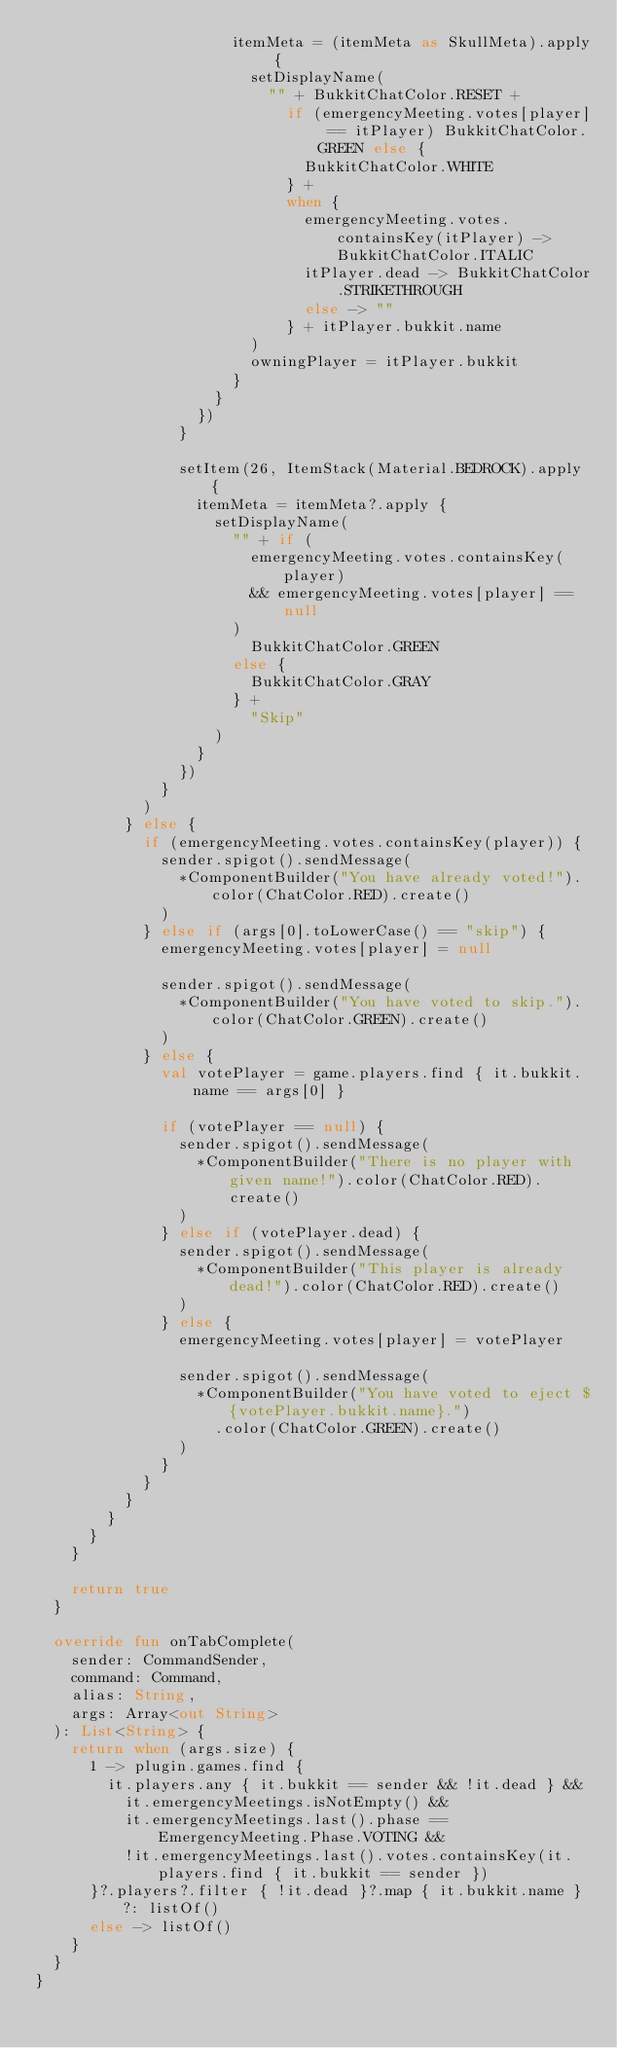<code> <loc_0><loc_0><loc_500><loc_500><_Kotlin_>                      itemMeta = (itemMeta as SkullMeta).apply {
                        setDisplayName(
                          "" + BukkitChatColor.RESET +
                            if (emergencyMeeting.votes[player] == itPlayer) BukkitChatColor.GREEN else {
                              BukkitChatColor.WHITE
                            } +
                            when {
                              emergencyMeeting.votes.containsKey(itPlayer) -> BukkitChatColor.ITALIC
                              itPlayer.dead -> BukkitChatColor.STRIKETHROUGH
                              else -> ""
                            } + itPlayer.bukkit.name
                        )
                        owningPlayer = itPlayer.bukkit
                      }
                    }
                  })
                }

                setItem(26, ItemStack(Material.BEDROCK).apply {
                  itemMeta = itemMeta?.apply {
                    setDisplayName(
                      "" + if (
                        emergencyMeeting.votes.containsKey(player)
                        && emergencyMeeting.votes[player] == null
                      )
                        BukkitChatColor.GREEN
                      else {
                        BukkitChatColor.GRAY
                      } +
                        "Skip"
                    )
                  }
                })
              }
            )
          } else {
            if (emergencyMeeting.votes.containsKey(player)) {
              sender.spigot().sendMessage(
                *ComponentBuilder("You have already voted!").color(ChatColor.RED).create()
              )
            } else if (args[0].toLowerCase() == "skip") {
              emergencyMeeting.votes[player] = null

              sender.spigot().sendMessage(
                *ComponentBuilder("You have voted to skip.").color(ChatColor.GREEN).create()
              )
            } else {
              val votePlayer = game.players.find { it.bukkit.name == args[0] }

              if (votePlayer == null) {
                sender.spigot().sendMessage(
                  *ComponentBuilder("There is no player with given name!").color(ChatColor.RED).create()
                )
              } else if (votePlayer.dead) {
                sender.spigot().sendMessage(
                  *ComponentBuilder("This player is already dead!").color(ChatColor.RED).create()
                )
              } else {
                emergencyMeeting.votes[player] = votePlayer

                sender.spigot().sendMessage(
                  *ComponentBuilder("You have voted to eject ${votePlayer.bukkit.name}.")
                    .color(ChatColor.GREEN).create()
                )
              }
            }
          }
        }
      }
    }

    return true
  }

  override fun onTabComplete(
    sender: CommandSender,
    command: Command,
    alias: String,
    args: Array<out String>
  ): List<String> {
    return when (args.size) {
      1 -> plugin.games.find {
        it.players.any { it.bukkit == sender && !it.dead } &&
          it.emergencyMeetings.isNotEmpty() &&
          it.emergencyMeetings.last().phase == EmergencyMeeting.Phase.VOTING &&
          !it.emergencyMeetings.last().votes.containsKey(it.players.find { it.bukkit == sender })
      }?.players?.filter { !it.dead }?.map { it.bukkit.name } ?: listOf()
      else -> listOf()
    }
  }
}
</code> 